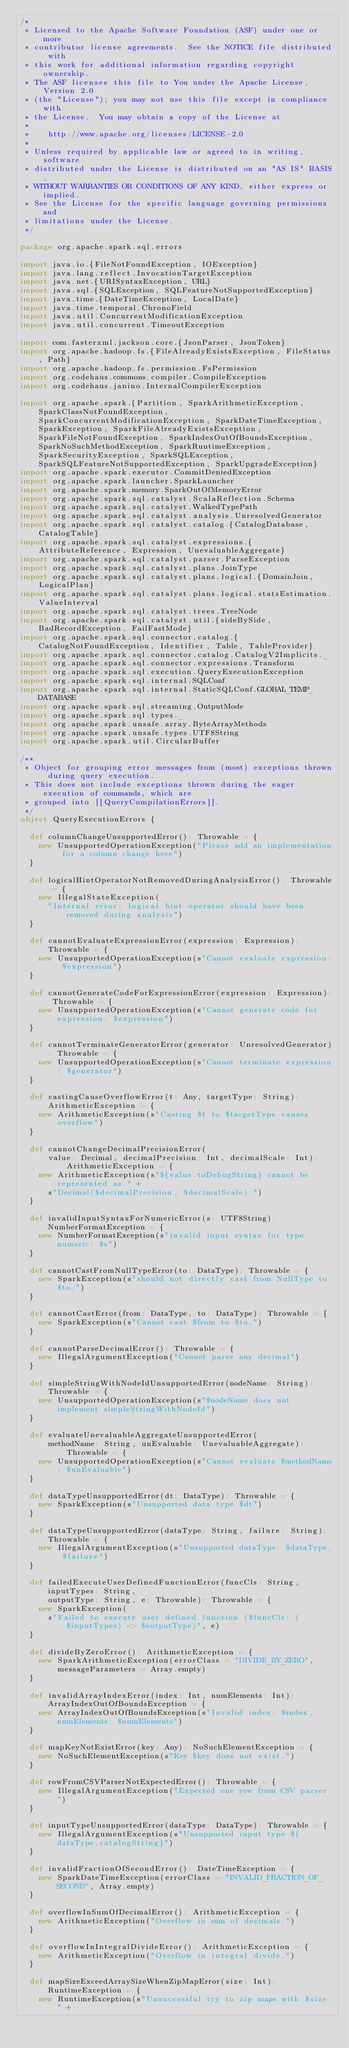Convert code to text. <code><loc_0><loc_0><loc_500><loc_500><_Scala_>/*
 * Licensed to the Apache Software Foundation (ASF) under one or more
 * contributor license agreements.  See the NOTICE file distributed with
 * this work for additional information regarding copyright ownership.
 * The ASF licenses this file to You under the Apache License, Version 2.0
 * (the "License"); you may not use this file except in compliance with
 * the License.  You may obtain a copy of the License at
 *
 *    http://www.apache.org/licenses/LICENSE-2.0
 *
 * Unless required by applicable law or agreed to in writing, software
 * distributed under the License is distributed on an "AS IS" BASIS,
 * WITHOUT WARRANTIES OR CONDITIONS OF ANY KIND, either express or implied.
 * See the License for the specific language governing permissions and
 * limitations under the License.
 */

package org.apache.spark.sql.errors

import java.io.{FileNotFoundException, IOException}
import java.lang.reflect.InvocationTargetException
import java.net.{URISyntaxException, URL}
import java.sql.{SQLException, SQLFeatureNotSupportedException}
import java.time.{DateTimeException, LocalDate}
import java.time.temporal.ChronoField
import java.util.ConcurrentModificationException
import java.util.concurrent.TimeoutException

import com.fasterxml.jackson.core.{JsonParser, JsonToken}
import org.apache.hadoop.fs.{FileAlreadyExistsException, FileStatus, Path}
import org.apache.hadoop.fs.permission.FsPermission
import org.codehaus.commons.compiler.CompileException
import org.codehaus.janino.InternalCompilerException

import org.apache.spark.{Partition, SparkArithmeticException, SparkClassNotFoundException, SparkConcurrentModificationException, SparkDateTimeException, SparkException, SparkFileAlreadyExistsException, SparkFileNotFoundException, SparkIndexOutOfBoundsException, SparkNoSuchMethodException, SparkRuntimeException, SparkSecurityException, SparkSQLException, SparkSQLFeatureNotSupportedException, SparkUpgradeException}
import org.apache.spark.executor.CommitDeniedException
import org.apache.spark.launcher.SparkLauncher
import org.apache.spark.memory.SparkOutOfMemoryError
import org.apache.spark.sql.catalyst.ScalaReflection.Schema
import org.apache.spark.sql.catalyst.WalkedTypePath
import org.apache.spark.sql.catalyst.analysis.UnresolvedGenerator
import org.apache.spark.sql.catalyst.catalog.{CatalogDatabase, CatalogTable}
import org.apache.spark.sql.catalyst.expressions.{AttributeReference, Expression, UnevaluableAggregate}
import org.apache.spark.sql.catalyst.parser.ParseException
import org.apache.spark.sql.catalyst.plans.JoinType
import org.apache.spark.sql.catalyst.plans.logical.{DomainJoin, LogicalPlan}
import org.apache.spark.sql.catalyst.plans.logical.statsEstimation.ValueInterval
import org.apache.spark.sql.catalyst.trees.TreeNode
import org.apache.spark.sql.catalyst.util.{sideBySide, BadRecordException, FailFastMode}
import org.apache.spark.sql.connector.catalog.{CatalogNotFoundException, Identifier, Table, TableProvider}
import org.apache.spark.sql.connector.catalog.CatalogV2Implicits._
import org.apache.spark.sql.connector.expressions.Transform
import org.apache.spark.sql.execution.QueryExecutionException
import org.apache.spark.sql.internal.SQLConf
import org.apache.spark.sql.internal.StaticSQLConf.GLOBAL_TEMP_DATABASE
import org.apache.spark.sql.streaming.OutputMode
import org.apache.spark.sql.types._
import org.apache.spark.unsafe.array.ByteArrayMethods
import org.apache.spark.unsafe.types.UTF8String
import org.apache.spark.util.CircularBuffer

/**
 * Object for grouping error messages from (most) exceptions thrown during query execution.
 * This does not include exceptions thrown during the eager execution of commands, which are
 * grouped into [[QueryCompilationErrors]].
 */
object QueryExecutionErrors {

  def columnChangeUnsupportedError(): Throwable = {
    new UnsupportedOperationException("Please add an implementation for a column change here")
  }

  def logicalHintOperatorNotRemovedDuringAnalysisError(): Throwable = {
    new IllegalStateException(
      "Internal error: logical hint operator should have been removed during analysis")
  }

  def cannotEvaluateExpressionError(expression: Expression): Throwable = {
    new UnsupportedOperationException(s"Cannot evaluate expression: $expression")
  }

  def cannotGenerateCodeForExpressionError(expression: Expression): Throwable = {
    new UnsupportedOperationException(s"Cannot generate code for expression: $expression")
  }

  def cannotTerminateGeneratorError(generator: UnresolvedGenerator): Throwable = {
    new UnsupportedOperationException(s"Cannot terminate expression: $generator")
  }

  def castingCauseOverflowError(t: Any, targetType: String): ArithmeticException = {
    new ArithmeticException(s"Casting $t to $targetType causes overflow")
  }

  def cannotChangeDecimalPrecisionError(
      value: Decimal, decimalPrecision: Int, decimalScale: Int): ArithmeticException = {
    new ArithmeticException(s"${value.toDebugString} cannot be represented as " +
      s"Decimal($decimalPrecision, $decimalScale).")
  }

  def invalidInputSyntaxForNumericError(s: UTF8String): NumberFormatException = {
    new NumberFormatException(s"invalid input syntax for type numeric: $s")
  }

  def cannotCastFromNullTypeError(to: DataType): Throwable = {
    new SparkException(s"should not directly cast from NullType to $to.")
  }

  def cannotCastError(from: DataType, to: DataType): Throwable = {
    new SparkException(s"Cannot cast $from to $to.")
  }

  def cannotParseDecimalError(): Throwable = {
    new IllegalArgumentException("Cannot parse any decimal")
  }

  def simpleStringWithNodeIdUnsupportedError(nodeName: String): Throwable = {
    new UnsupportedOperationException(s"$nodeName does not implement simpleStringWithNodeId")
  }

  def evaluateUnevaluableAggregateUnsupportedError(
      methodName: String, unEvaluable: UnevaluableAggregate): Throwable = {
    new UnsupportedOperationException(s"Cannot evaluate $methodName: $unEvaluable")
  }

  def dataTypeUnsupportedError(dt: DataType): Throwable = {
    new SparkException(s"Unsupported data type $dt")
  }

  def dataTypeUnsupportedError(dataType: String, failure: String): Throwable = {
    new IllegalArgumentException(s"Unsupported dataType: $dataType, $failure")
  }

  def failedExecuteUserDefinedFunctionError(funcCls: String, inputTypes: String,
      outputType: String, e: Throwable): Throwable = {
    new SparkException(
      s"Failed to execute user defined function ($funcCls: ($inputTypes) => $outputType)", e)
  }

  def divideByZeroError(): ArithmeticException = {
    new SparkArithmeticException(errorClass = "DIVIDE_BY_ZERO", messageParameters = Array.empty)
  }

  def invalidArrayIndexError(index: Int, numElements: Int): ArrayIndexOutOfBoundsException = {
    new ArrayIndexOutOfBoundsException(s"Invalid index: $index, numElements: $numElements")
  }

  def mapKeyNotExistError(key: Any): NoSuchElementException = {
    new NoSuchElementException(s"Key $key does not exist.")
  }

  def rowFromCSVParserNotExpectedError(): Throwable = {
    new IllegalArgumentException("Expected one row from CSV parser.")
  }

  def inputTypeUnsupportedError(dataType: DataType): Throwable = {
    new IllegalArgumentException(s"Unsupported input type ${dataType.catalogString}")
  }

  def invalidFractionOfSecondError(): DateTimeException = {
    new SparkDateTimeException(errorClass = "INVALID_FRACTION_OF_SECOND", Array.empty)
  }

  def overflowInSumOfDecimalError(): ArithmeticException = {
    new ArithmeticException("Overflow in sum of decimals.")
  }

  def overflowInIntegralDivideError(): ArithmeticException = {
    new ArithmeticException("Overflow in integral divide.")
  }

  def mapSizeExceedArraySizeWhenZipMapError(size: Int): RuntimeException = {
    new RuntimeException(s"Unsuccessful try to zip maps with $size " +</code> 